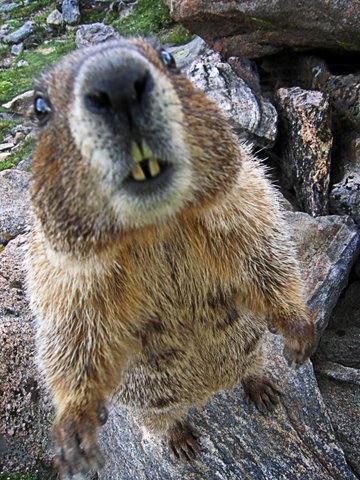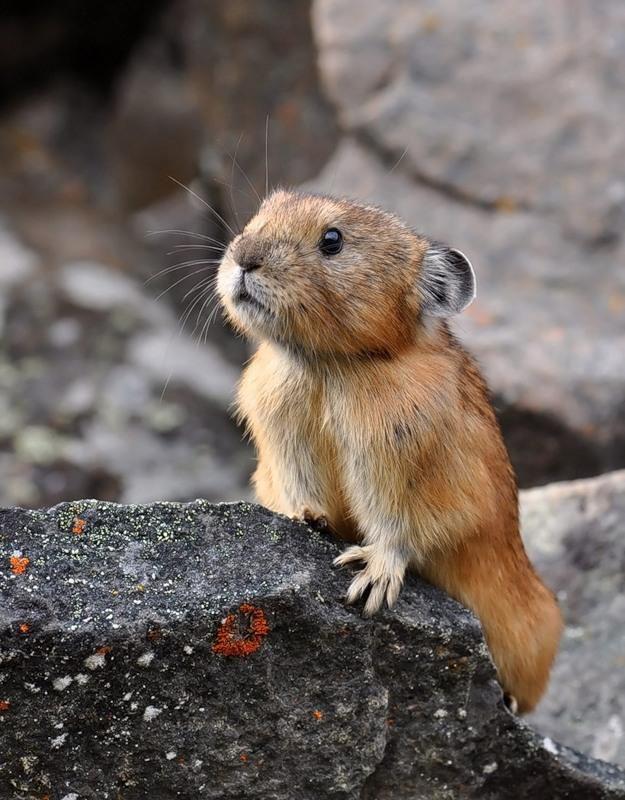The first image is the image on the left, the second image is the image on the right. Given the left and right images, does the statement "Marmot in right image is standing up with arms dangling in front." hold true? Answer yes or no. No. The first image is the image on the left, the second image is the image on the right. Assess this claim about the two images: "the animal in the image on the left is facing right". Correct or not? Answer yes or no. No. 